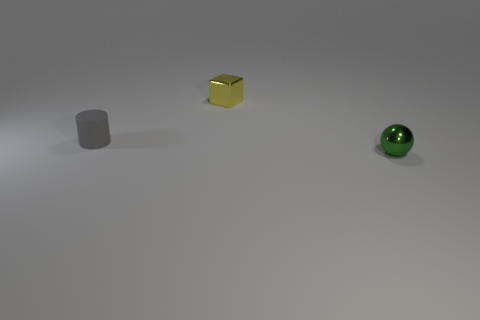Subtract all cylinders. How many objects are left? 2 Add 1 small metallic cubes. How many objects exist? 4 Subtract 1 cubes. How many cubes are left? 0 Add 1 yellow metallic things. How many yellow metallic things are left? 2 Add 3 large cyan metallic cylinders. How many large cyan metallic cylinders exist? 3 Subtract 0 blue cylinders. How many objects are left? 3 Subtract all gray cubes. Subtract all blue balls. How many cubes are left? 1 Subtract all green spheres. How many red cylinders are left? 0 Subtract all tiny yellow cubes. Subtract all spheres. How many objects are left? 1 